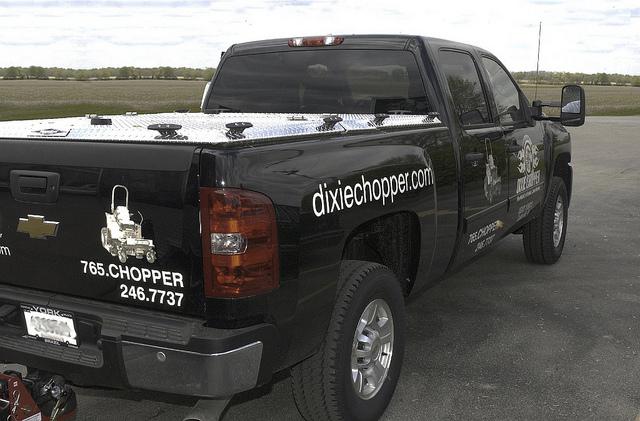What does the vehicle say on the back?
Answer briefly. 765chopper 246.7737. What color is the truck?
Keep it brief. Black. What phone number is on the back?
Give a very brief answer. 246.7737. What is the phone number?
Answer briefly. 2467737. What state is the truck from?
Quick response, please. New york. How many tires do you see?
Concise answer only. 2. What picture is on the back of the truck?
Quick response, please. Lawn mower. 